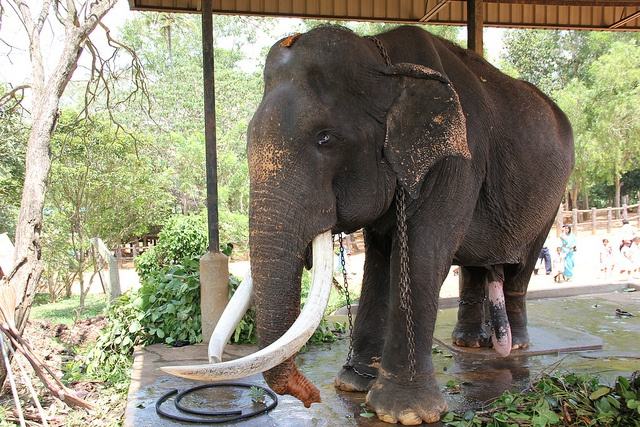Describe the objects in this image and their specific colors. I can see elephant in violet, black, and gray tones, people in violet, white, lightblue, and tan tones, people in violet, white, lightpink, tan, and salmon tones, people in violet, white, lightpink, tan, and salmon tones, and people in violet, white, gray, and darkgray tones in this image. 